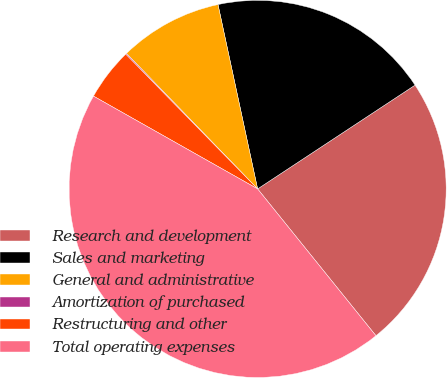<chart> <loc_0><loc_0><loc_500><loc_500><pie_chart><fcel>Research and development<fcel>Sales and marketing<fcel>General and administrative<fcel>Amortization of purchased<fcel>Restructuring and other<fcel>Total operating expenses<nl><fcel>23.48%<fcel>19.09%<fcel>8.87%<fcel>0.09%<fcel>4.48%<fcel>43.98%<nl></chart> 